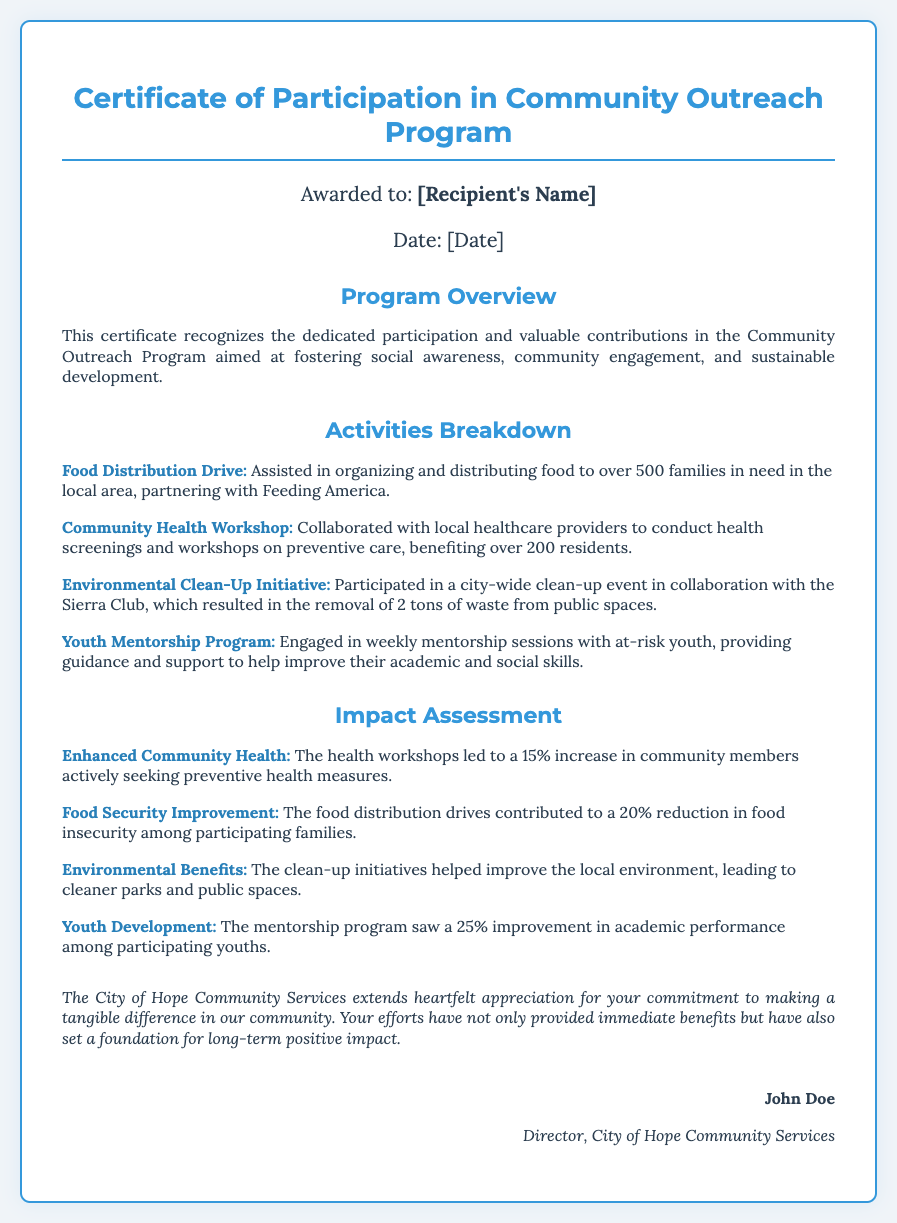What is the recipient's name? The document mentions the recipient's name as [Recipient's Name], which is a placeholder that would be substituted with the actual name in a rendered certificate.
Answer: [Recipient's Name] What is the date on the certificate? The date is presented in the document as a placeholder [Date], which is to be filled with the actual certificate issuance date.
Answer: [Date] How many families were assisted during the Food Distribution Drive? The Food Distribution Drive details state that over 500 families were served, as noted in the activities breakdown.
Answer: over 500 families Which organization partnered for the Environmental Clean-Up Initiative? The document specifies that the Sierra Club collaborated in the Environmental Clean-Up Initiative, indicated in the activities section.
Answer: Sierra Club What percentage of youth showed improved academic performance? In the impact assessment, there is a note stating a 25% improvement in academic performance among participating youths in the mentorship program.
Answer: 25% What has been the impact on food security? The impact assessment notes a 20% reduction in food insecurity among participating families due to the food distribution drives.
Answer: 20% How many residents benefited from the Community Health Workshop? The document states that over 200 residents benefited from the community health workshops conducted by local healthcare providers.
Answer: over 200 residents What type of program is recognized by this certificate? The certificate recognizes participation in a Community Outreach Program, as indicated in the program overview.
Answer: Community Outreach Program Who is the signatory of the certificate? The document cites John Doe as the signatory, identified as the Director of City of Hope Community Services.
Answer: John Doe 